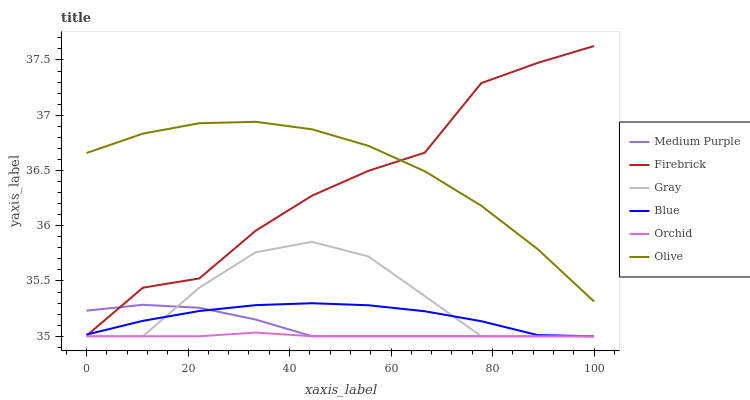Does Orchid have the minimum area under the curve?
Answer yes or no. Yes. Does Olive have the maximum area under the curve?
Answer yes or no. Yes. Does Gray have the minimum area under the curve?
Answer yes or no. No. Does Gray have the maximum area under the curve?
Answer yes or no. No. Is Orchid the smoothest?
Answer yes or no. Yes. Is Firebrick the roughest?
Answer yes or no. Yes. Is Gray the smoothest?
Answer yes or no. No. Is Gray the roughest?
Answer yes or no. No. Does Firebrick have the lowest value?
Answer yes or no. No. Does Firebrick have the highest value?
Answer yes or no. Yes. Does Gray have the highest value?
Answer yes or no. No. Is Medium Purple less than Olive?
Answer yes or no. Yes. Is Olive greater than Medium Purple?
Answer yes or no. Yes. Does Firebrick intersect Olive?
Answer yes or no. Yes. Is Firebrick less than Olive?
Answer yes or no. No. Is Firebrick greater than Olive?
Answer yes or no. No. Does Medium Purple intersect Olive?
Answer yes or no. No. 